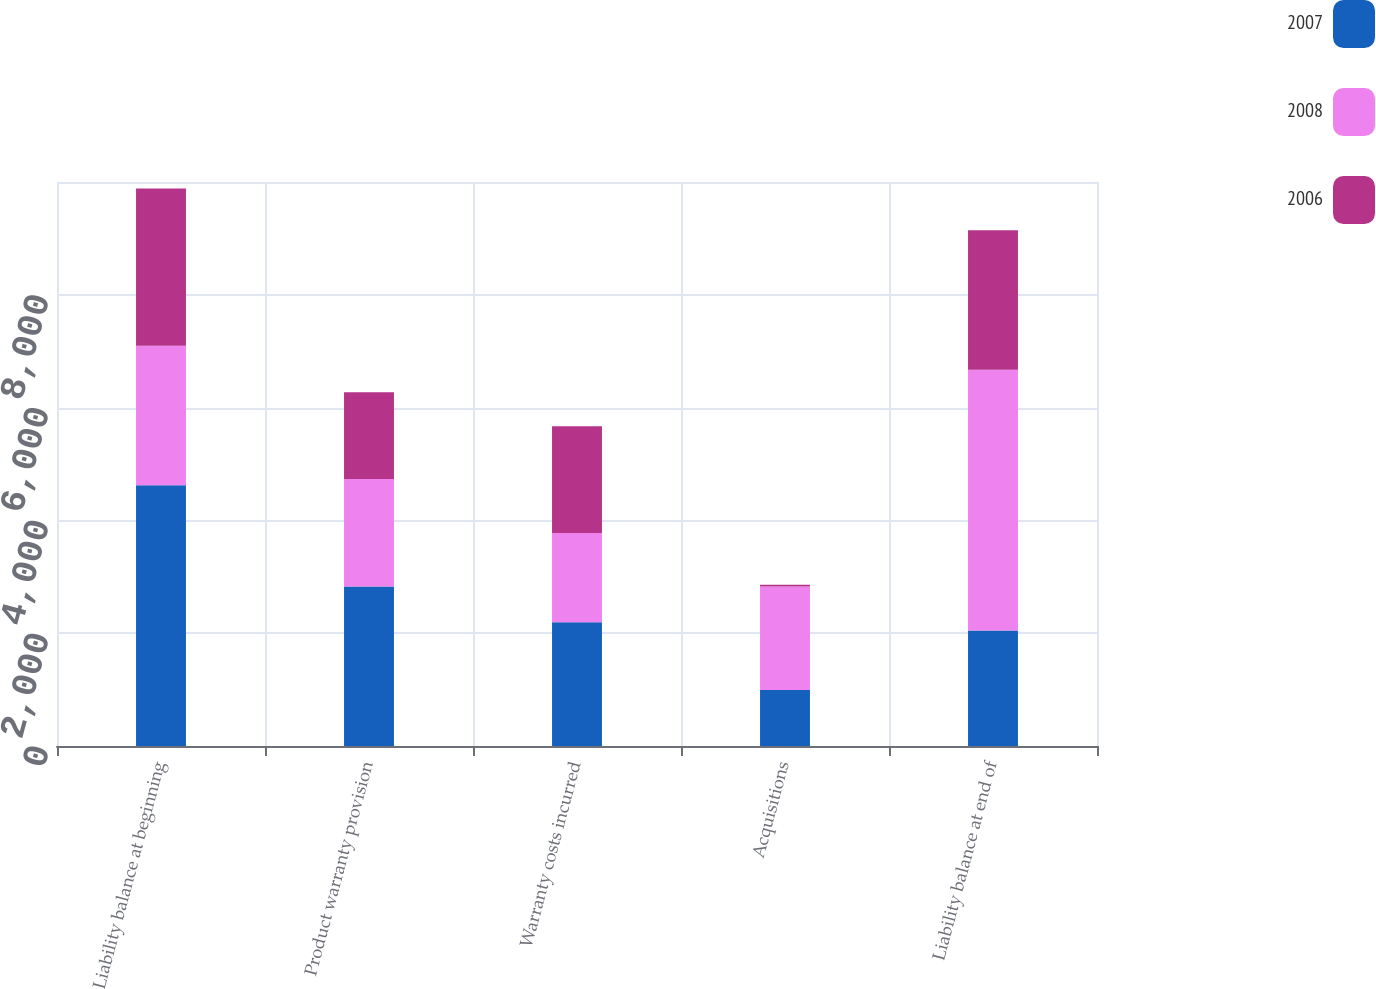Convert chart to OTSL. <chart><loc_0><loc_0><loc_500><loc_500><stacked_bar_chart><ecel><fcel>Liability balance at beginning<fcel>Product warranty provision<fcel>Warranty costs incurred<fcel>Acquisitions<fcel>Liability balance at end of<nl><fcel>2007<fcel>4624<fcel>2829<fcel>2192<fcel>994<fcel>2047.5<nl><fcel>2008<fcel>2472<fcel>1903<fcel>1586<fcel>1835<fcel>4624<nl><fcel>2006<fcel>2789<fcel>1541<fcel>1890<fcel>32<fcel>2472<nl></chart> 